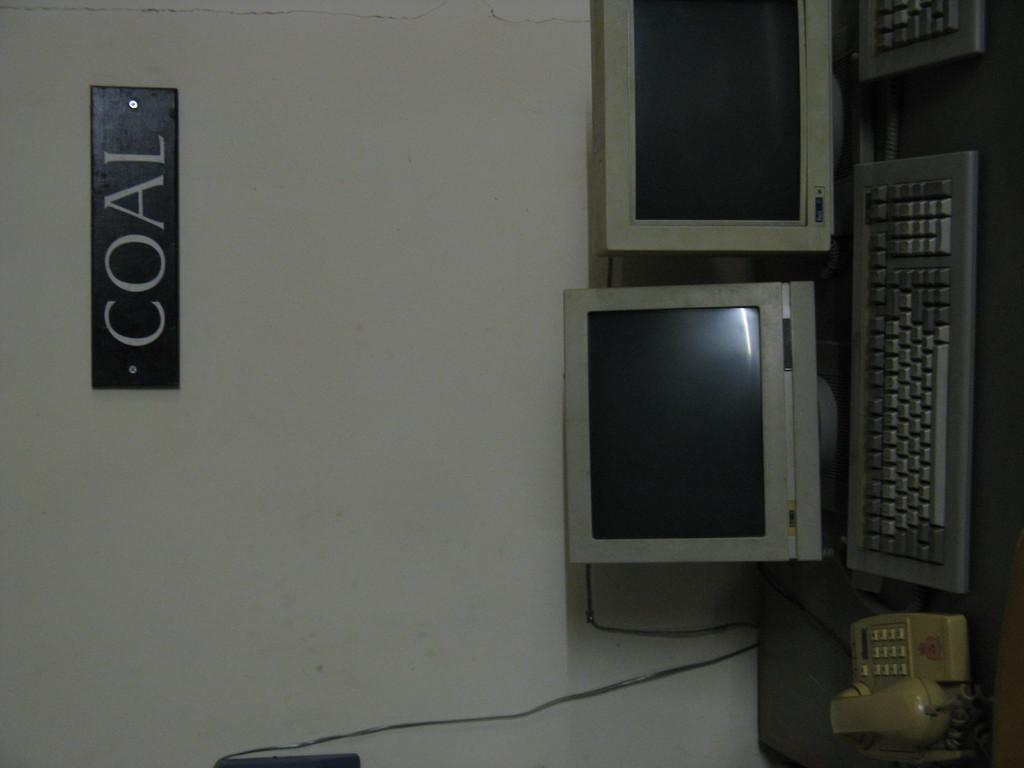What is the label on the wall above these computers?
Provide a succinct answer. Coal. 